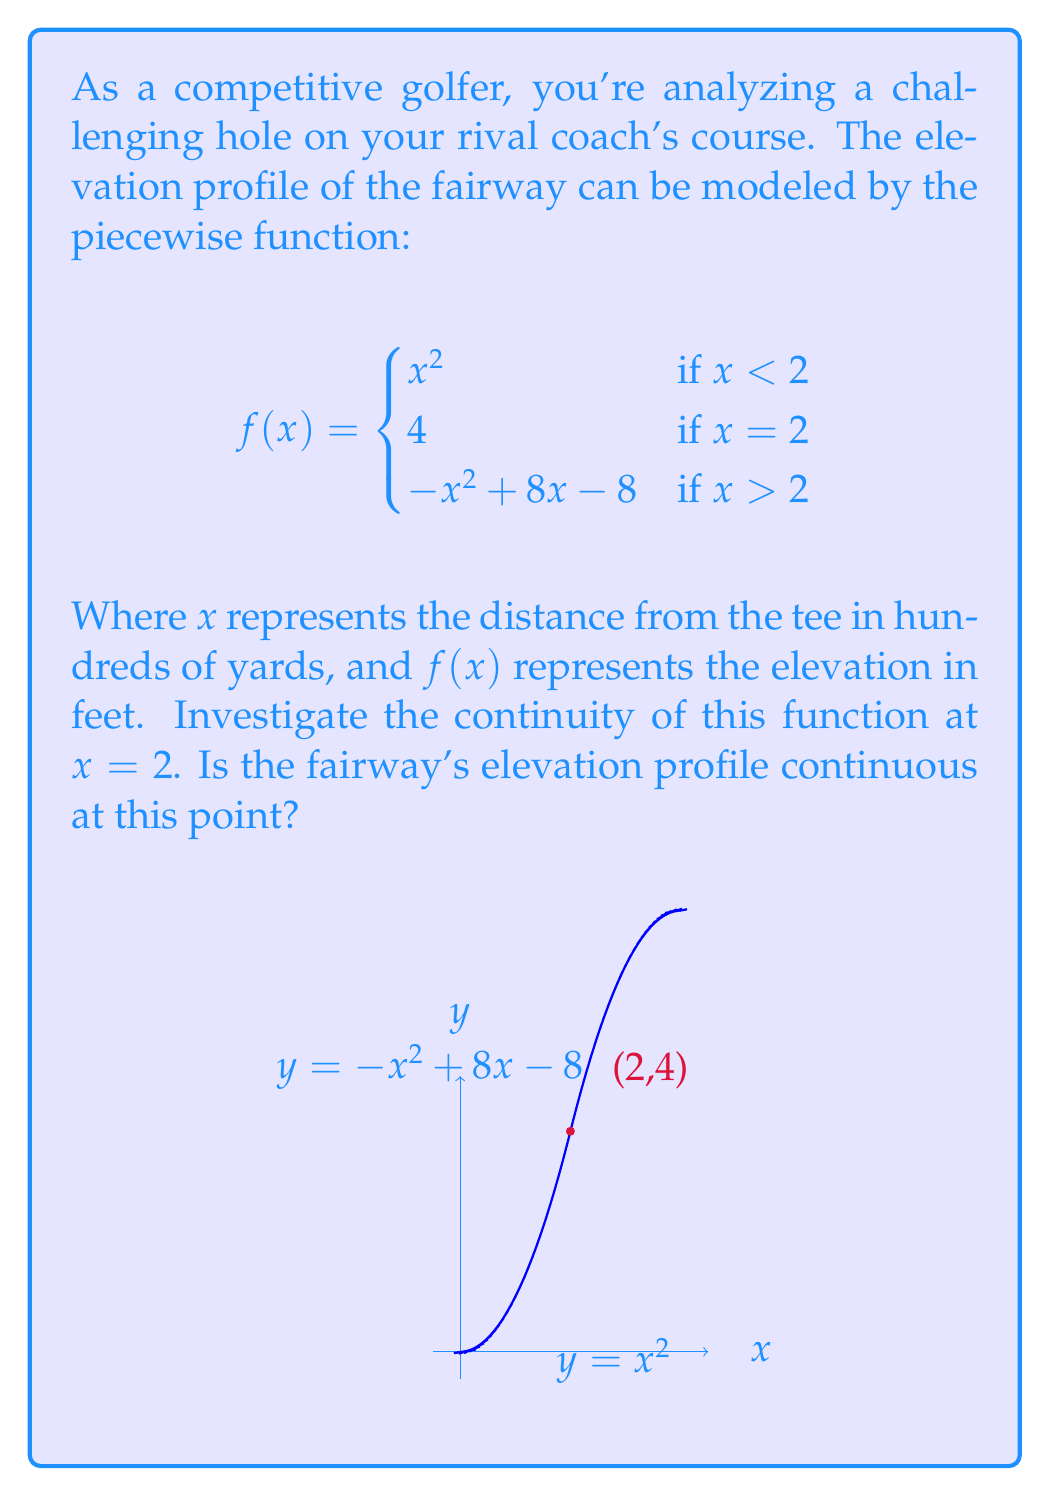Solve this math problem. To investigate the continuity at $x = 2$, we need to check three conditions:

1) $f(2)$ exists
2) $\lim_{x \to 2^-} f(x)$ exists
3) $\lim_{x \to 2^+} f(x)$ exists
4) All three values are equal

Step 1: Check if $f(2)$ exists
From the given function, $f(2) = 4$. So $f(2)$ exists.

Step 2: Calculate $\lim_{x \to 2^-} f(x)$
As $x$ approaches 2 from the left, we use the first piece of the function:
$$\lim_{x \to 2^-} f(x) = \lim_{x \to 2^-} x^2 = 2^2 = 4$$

Step 3: Calculate $\lim_{x \to 2^+} f(x)$
As $x$ approaches 2 from the right, we use the third piece of the function:
$$\lim_{x \to 2^+} f(x) = \lim_{x \to 2^+} (-x^2 + 8x - 8) = -(2^2) + 8(2) - 8 = -4 + 16 - 8 = 4$$

Step 4: Compare the values
We have:
- $f(2) = 4$
- $\lim_{x \to 2^-} f(x) = 4$
- $\lim_{x \to 2^+} f(x) = 4$

All three values are equal to 4, satisfying all conditions for continuity at $x = 2$.
Answer: Yes, the fairway's elevation profile is continuous at $x = 2$. 